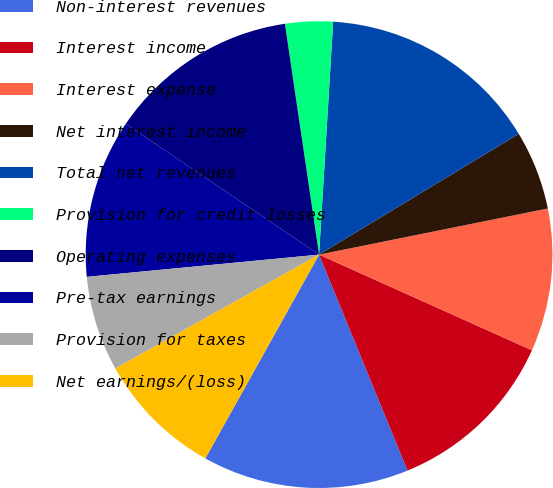<chart> <loc_0><loc_0><loc_500><loc_500><pie_chart><fcel>Non-interest revenues<fcel>Interest income<fcel>Interest expense<fcel>Net interest income<fcel>Total net revenues<fcel>Provision for credit losses<fcel>Operating expenses<fcel>Pre-tax earnings<fcel>Provision for taxes<fcel>Net earnings/(loss)<nl><fcel>14.29%<fcel>12.09%<fcel>9.89%<fcel>5.49%<fcel>15.38%<fcel>3.3%<fcel>13.19%<fcel>10.99%<fcel>6.59%<fcel>8.79%<nl></chart> 